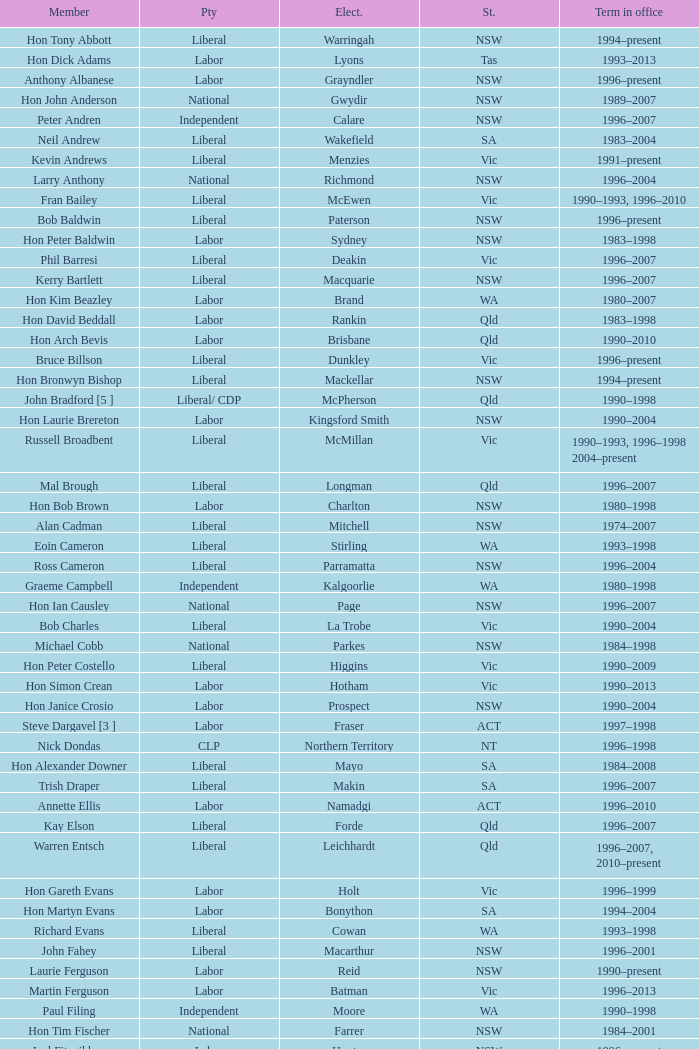In what state was the electorate fowler? NSW. 